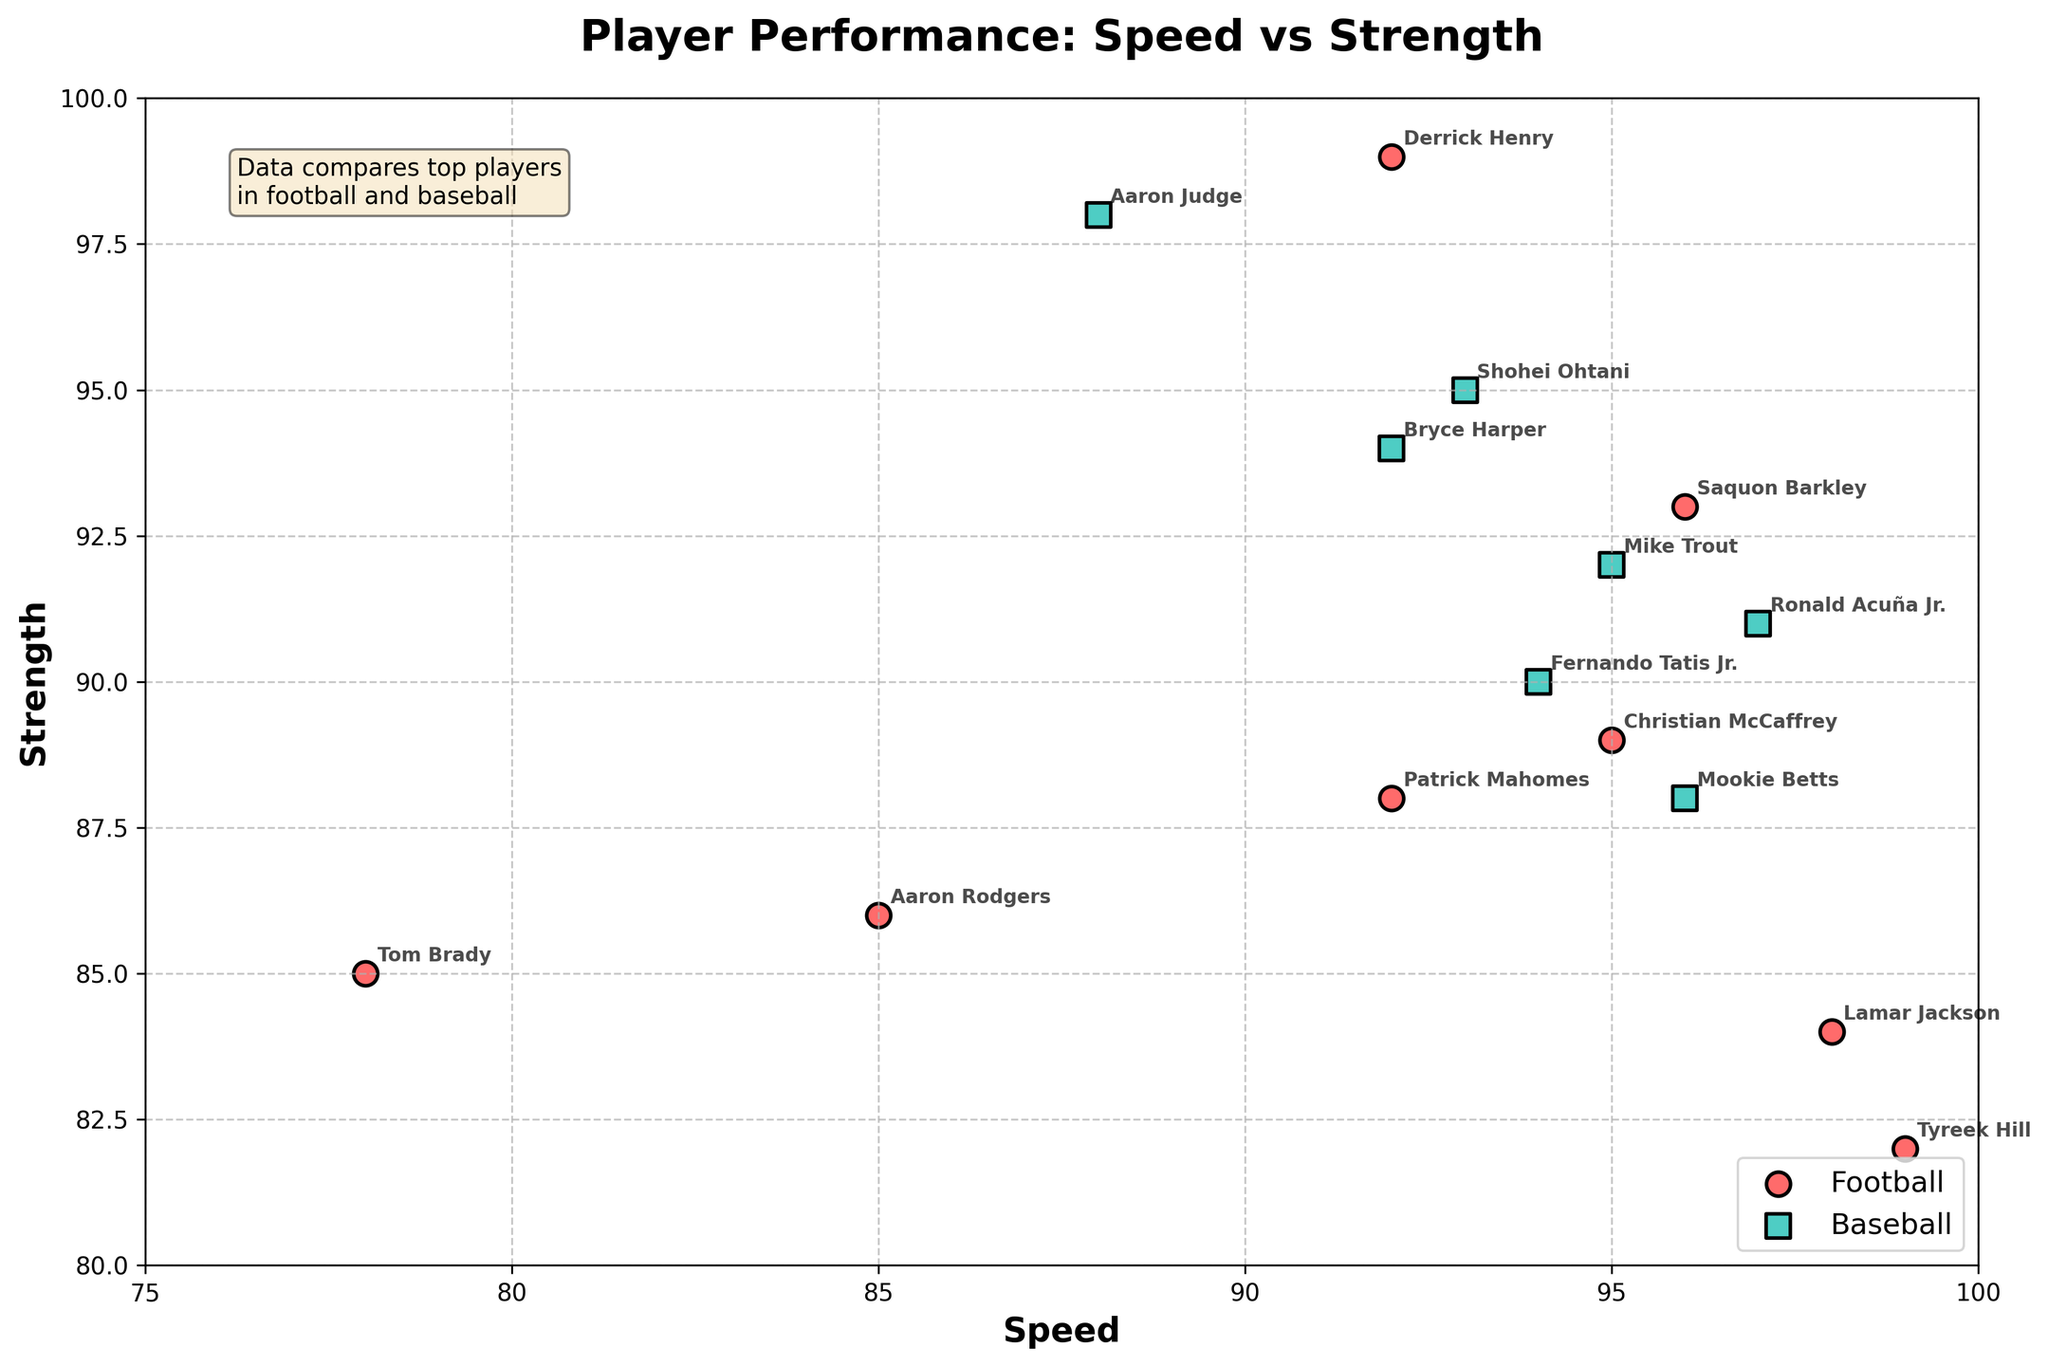What's the title of the plot? The plot's title is generally located at the top of the figure and is used to summarize the presented data. In this case, the title reads "Player Performance: Speed vs Strength."
Answer: Player Performance: Speed vs Strength How many football players are represented in the plot? The data points for football players are marked with circular shapes, distinguished by a specific color (red). By counting these shapes, we can determine the number of football players. There are 8 football players represented.
Answer: 8 Which player has the highest speed among all football players? The plot features speed on the x-axis. The football player data points are marked in red. The player situated furthest to the right among the red points has the highest speed is Tyreek Hill at 99.
Answer: Tyreek Hill Which baseball player has the highest strength? The y-axis represents strength. The data points for baseball players are in green square shapes. The player positioned highest among the green squares has the greatest strength. This player is Aaron Judge with a strength rating of 98.
Answer: Aaron Judge What is the average speed of the baseball players? Sum the speeds of all baseball players: (95 + 92 + 96 + 94 + 88 + 97 + 93) = 655. Divide by the number of players (7). Thus, the average speed is 655 / 7 ≈ 93.57.
Answer: 93.57 Which player has the closest combination of speed and strength? The closest points to each other in terms of position on the plot would have similar values for both axes. Comparing speeds and strengths directly reveals that Saquon Barkley has a speed of 96 and a strength of 93, making them one of the closest combinations.
Answer: Saquon Barkley Who has the highest combination of speed and strength among all players? To determine this, compare the sum of each player's speed and strength. The highest combined value is Derrick Henry (speed 92, strength 99), giving a score of 92 + 99 = 191.
Answer: Derrick Henry Among the football players, who has the lowest strength? The football players' strength is marked on the y-axis, indicated in red. The player with the point positioned at the lowest y-value among the reds is Tyreek Hill at 82.
Answer: Tyreek Hill What is the difference in strength between the strongest football player and the strongest baseball player? The plot indicates the strongest football player is Derrick Henry (strength 99), and the strongest baseball player is Aaron Judge (strength 98). The difference in strength is 99 - 98 = 1.
Answer: 1 Which sport has players with a wider range of speeds? Examining the spread on the x-axis for both sports, football players span from 78 (Tom Brady) to 99 (Tyreek Hill), giving a range of 99 - 78 = 21 units. Baseball players range from 88 (Aaron Judge) to 97 (Ronald Acuña Jr.), giving a range of 97 - 88 = 9 units. Football shows a wider range.
Answer: Football 